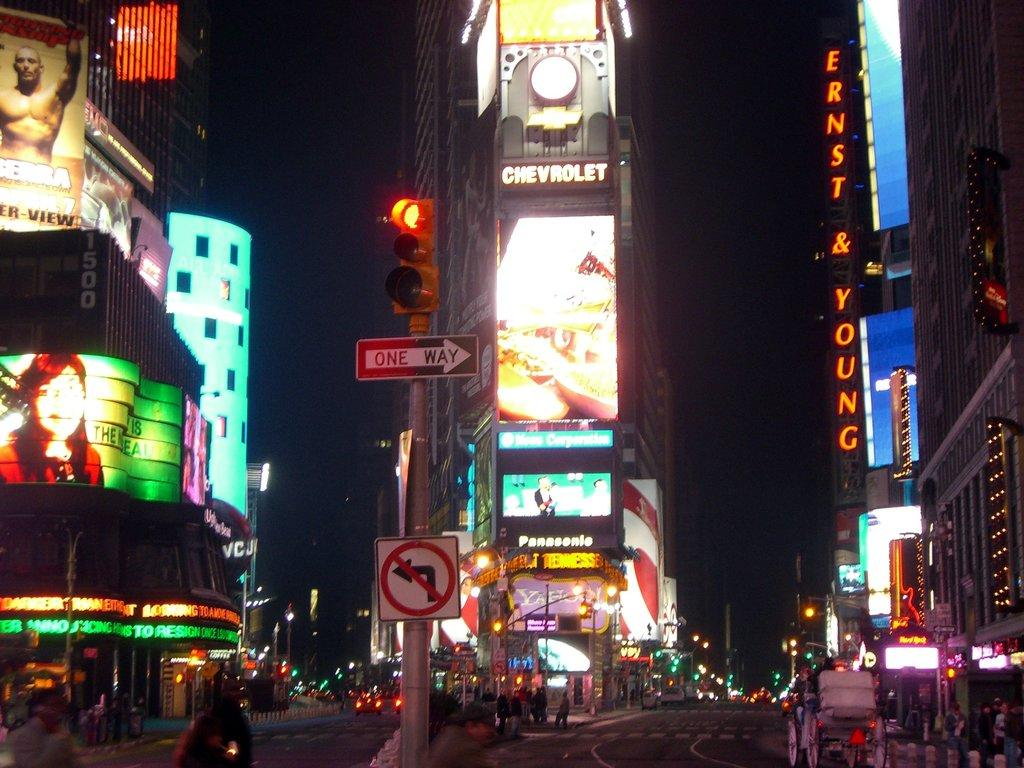Provide a one-sentence caption for the provided image. The middle of a city square that says chevrolet. 